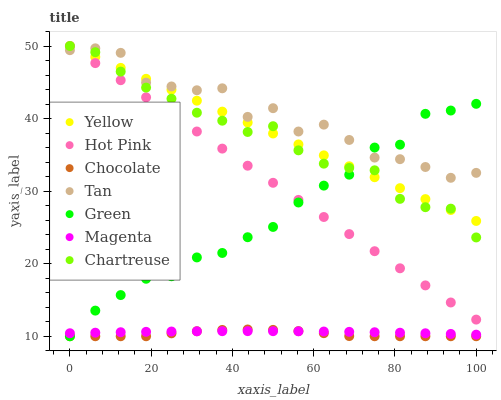Does Chocolate have the minimum area under the curve?
Answer yes or no. Yes. Does Tan have the maximum area under the curve?
Answer yes or no. Yes. Does Yellow have the minimum area under the curve?
Answer yes or no. No. Does Yellow have the maximum area under the curve?
Answer yes or no. No. Is Yellow the smoothest?
Answer yes or no. Yes. Is Tan the roughest?
Answer yes or no. Yes. Is Chocolate the smoothest?
Answer yes or no. No. Is Chocolate the roughest?
Answer yes or no. No. Does Chocolate have the lowest value?
Answer yes or no. Yes. Does Yellow have the lowest value?
Answer yes or no. No. Does Chartreuse have the highest value?
Answer yes or no. Yes. Does Chocolate have the highest value?
Answer yes or no. No. Is Chocolate less than Tan?
Answer yes or no. Yes. Is Yellow greater than Chocolate?
Answer yes or no. Yes. Does Green intersect Magenta?
Answer yes or no. Yes. Is Green less than Magenta?
Answer yes or no. No. Is Green greater than Magenta?
Answer yes or no. No. Does Chocolate intersect Tan?
Answer yes or no. No. 